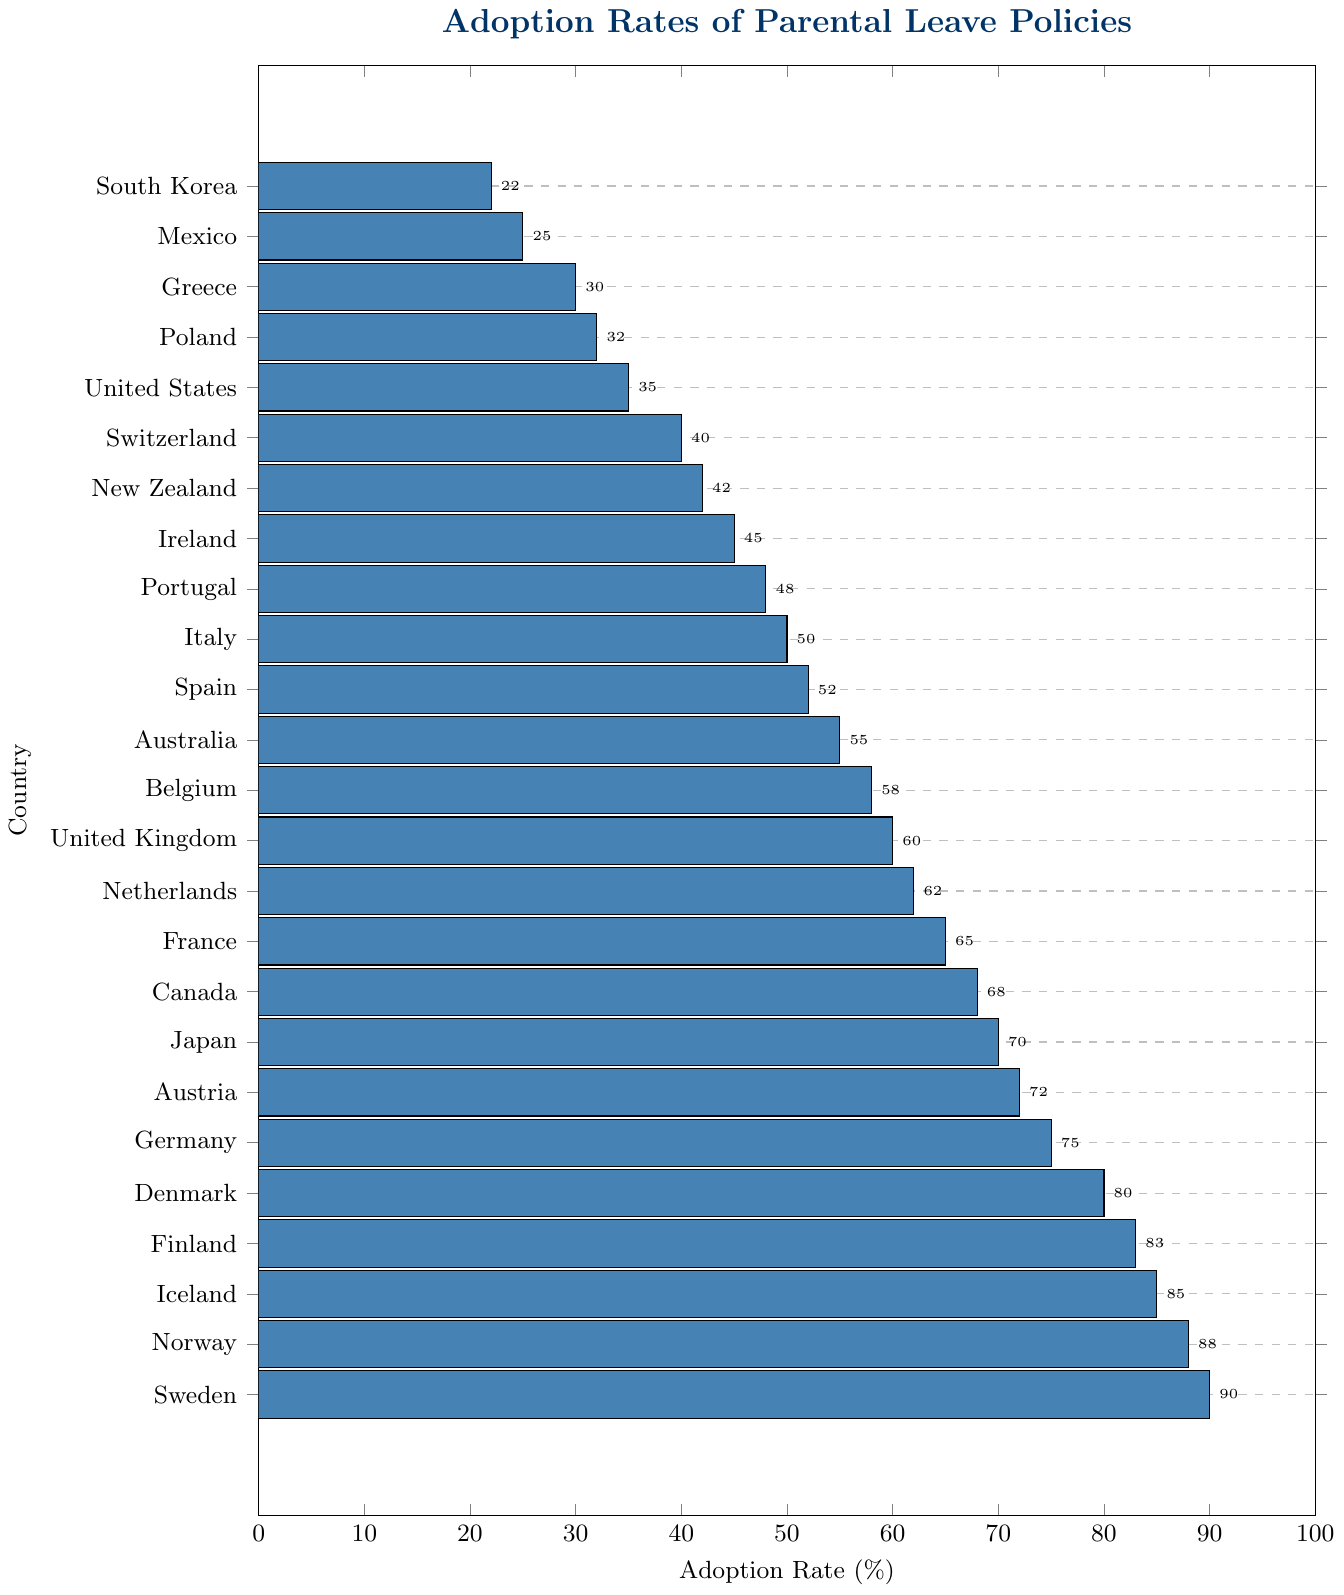Which country has the highest adoption rate of parental leave policies? The bar chart shows that Sweden has the highest adoption rate at 90%.
Answer: Sweden Which country has the lowest adoption rate of parental leave policies? The bar chart shows that South Korea has the lowest adoption rate at 22%.
Answer: South Korea What is the difference in adoption rates between Norway and the United States? Norway has an adoption rate of 88% and the United States has an adoption rate of 35%. The difference is 88% - 35% = 53%.
Answer: 53% Which countries have adoption rates greater than 80%? The countries with adoption rates greater than 80% are Sweden (90%), Norway (88%), Iceland (85%), and Finland (83%).
Answer: Sweden, Norway, Iceland, Finland What is the average adoption rate for the top 5 countries? The top 5 countries are Sweden (90%), Norway (88%), Iceland (85%), Finland (83%), and Denmark (80%). The average is (90 + 88 + 85 + 83 + 80) / 5 = 85.2%.
Answer: 85.2% Compare the adoption rates of parental leave policies in Japan and Germany. Which country has a higher rate and by how much? Germany has an adoption rate of 75% and Japan has an adoption rate of 70%. Germany has a higher rate by 75% - 70% = 5%.
Answer: Germany, 5% Is the adoption rate of parental leave policies in the United Kingdom higher or lower than in France? The United Kingdom has an adoption rate of 60% and France has an adoption rate of 65%, so the United Kingdom has a lower adoption rate.
Answer: Lower What is the median adoption rate among the listed countries? There are 25 countries listed. The median is the 13th value when sorted in ascending order, which is Belgium with an adoption rate of 58%.
Answer: 58% Which country ranks 10th in terms of adoption rates of parental leave policies? The bar chart shows that Italy ranks 10th with an adoption rate of 50%.
Answer: Italy How many countries have adoption rates below 50%? The countries with adoption rates below 50% are Portugal (48%), Ireland (45%), New Zealand (42%), Switzerland (40%), United States (35%), Poland (32%), Greece (30%), Mexico (25%), and South Korea (22%). There are 9 countries in total.
Answer: 9 